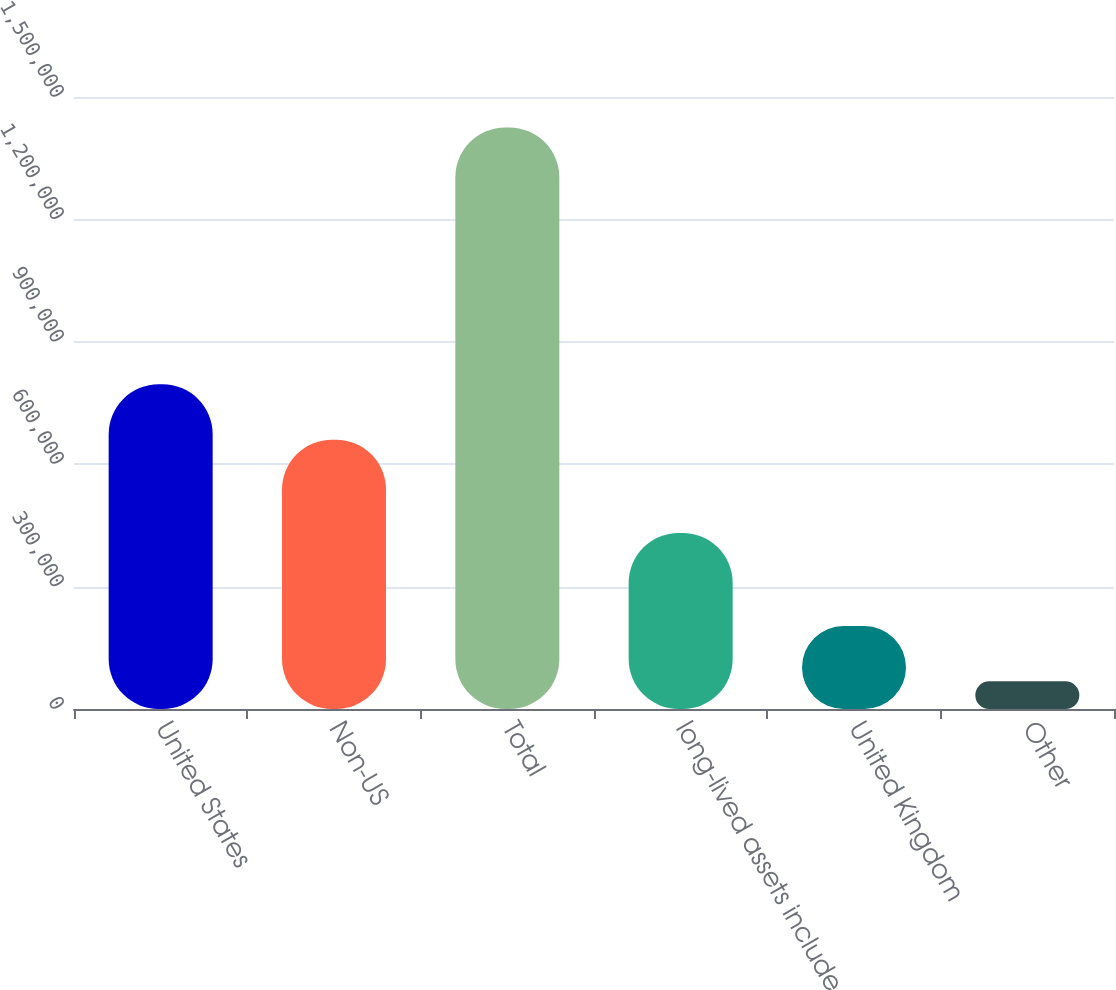Convert chart. <chart><loc_0><loc_0><loc_500><loc_500><bar_chart><fcel>United States<fcel>Non-US<fcel>Total<fcel>long-lived assets include<fcel>United Kingdom<fcel>Other<nl><fcel>795854<fcel>660098<fcel>1.4253e+06<fcel>431627<fcel>203494<fcel>67738<nl></chart> 